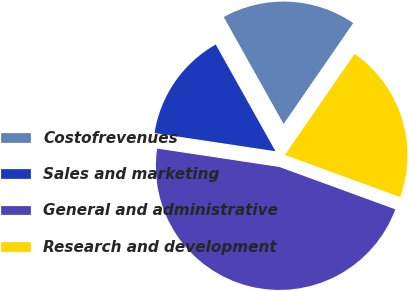Convert chart to OTSL. <chart><loc_0><loc_0><loc_500><loc_500><pie_chart><fcel>Costofrevenues<fcel>Sales and marketing<fcel>General and administrative<fcel>Research and development<nl><fcel>17.73%<fcel>14.5%<fcel>46.8%<fcel>20.96%<nl></chart> 